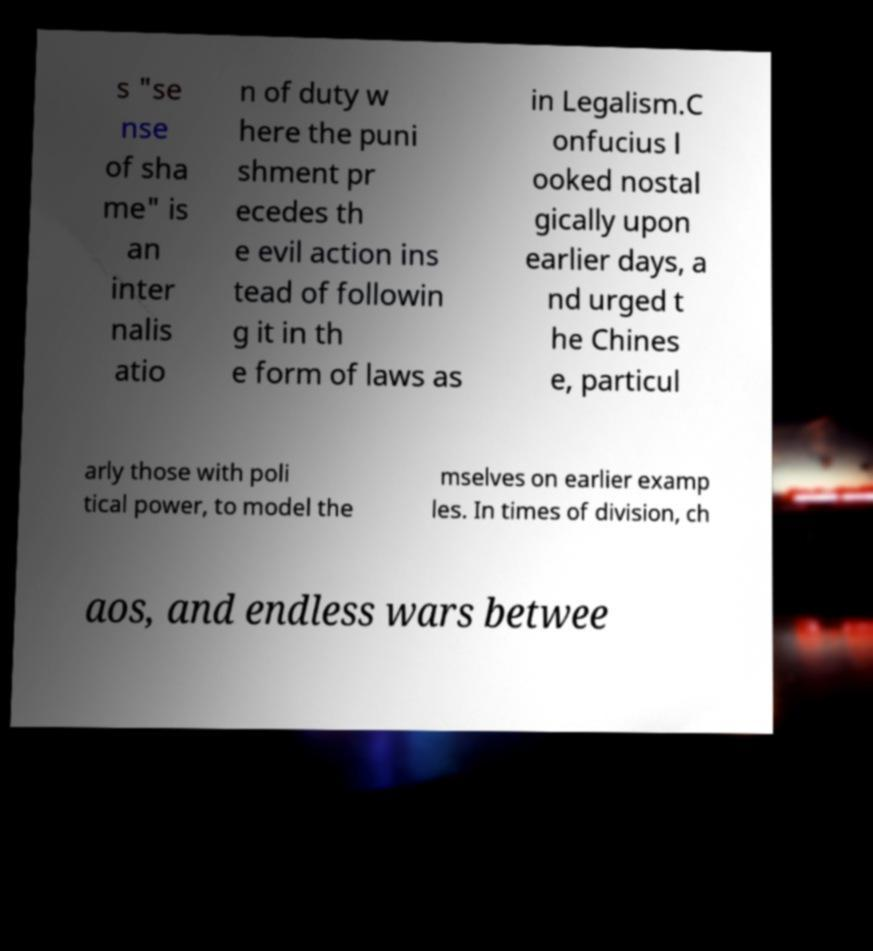Please read and relay the text visible in this image. What does it say? s "se nse of sha me" is an inter nalis atio n of duty w here the puni shment pr ecedes th e evil action ins tead of followin g it in th e form of laws as in Legalism.C onfucius l ooked nostal gically upon earlier days, a nd urged t he Chines e, particul arly those with poli tical power, to model the mselves on earlier examp les. In times of division, ch aos, and endless wars betwee 